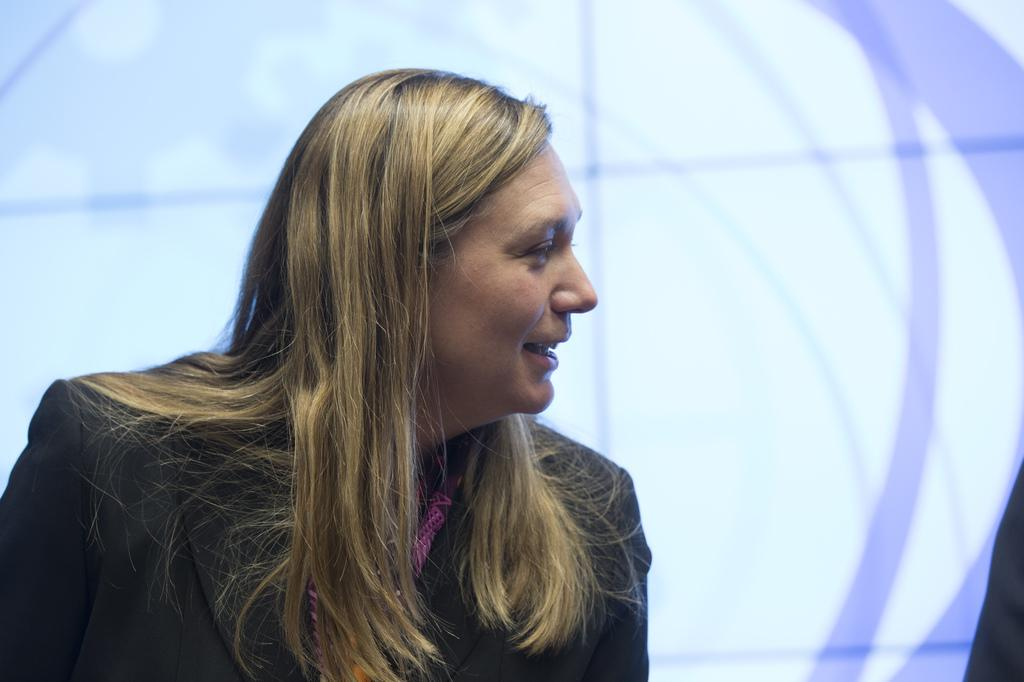Who is the main subject in the image? There is a woman in the image. What is the woman wearing? The woman is wearing a suit. What expression does the woman have? The woman is smiling. In which direction is the woman looking? The woman is looking to the right side. What is the color of the background in the image? The background of the image is white. What type of tomatoes can be seen in the image? There are no tomatoes present in the image. What is the woman's taste in music, based on the image? The image does not provide any information about the woman's taste in music. 